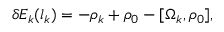<formula> <loc_0><loc_0><loc_500><loc_500>\delta E _ { k } ( l _ { k } ) = - \rho _ { k } + \rho _ { 0 } - [ \Omega _ { k } , \rho _ { 0 } ] ,</formula> 